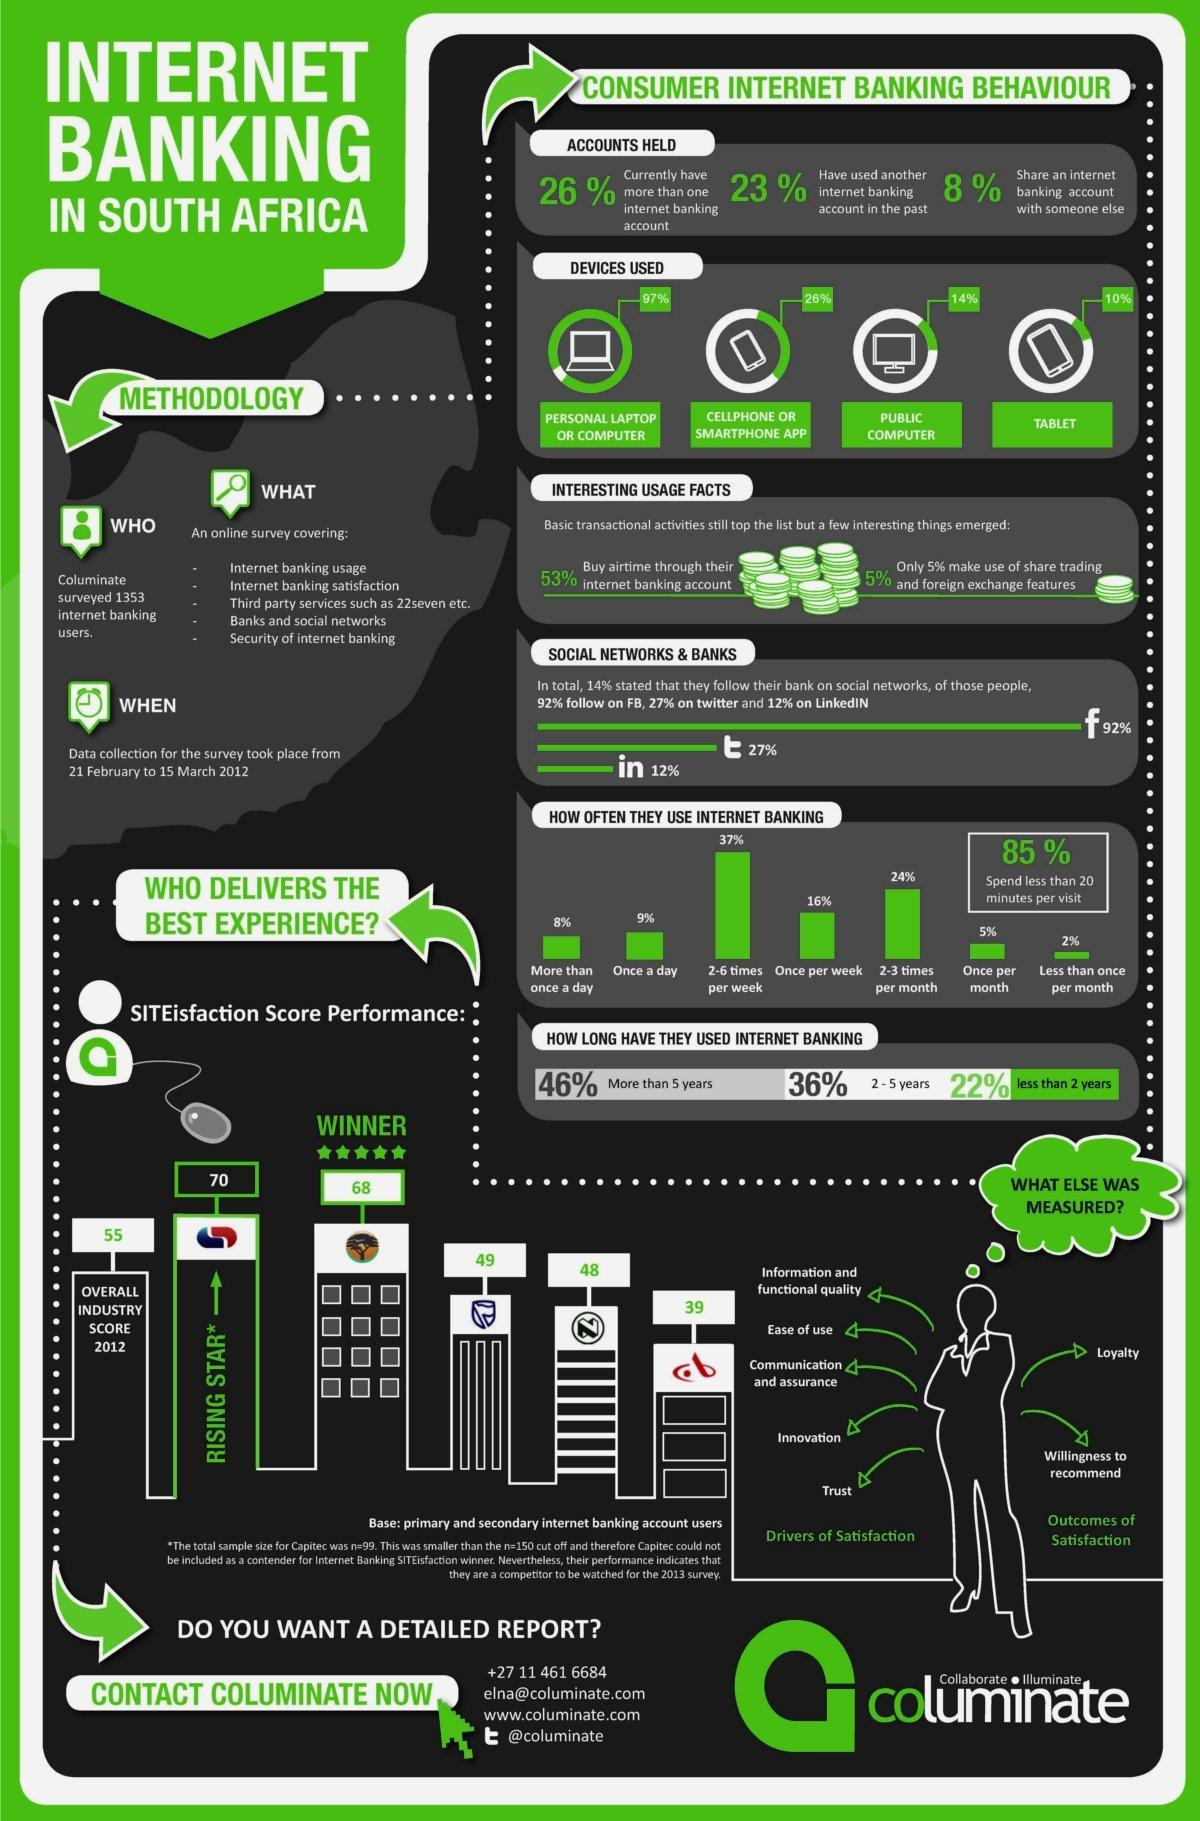Specify some key components in this picture. According to a survey conducted in 2012, 26% of consumers in South Africa use internet banking via their smartphone app. According to a survey conducted in South Africa in 2012, only 5% of consumers used internet banking on a monthly basis. A survey conducted in South Africa in 2012 showed that tablets were the least commonly used device for internet banking among consumers. According to a survey conducted in 2012 in South Africa, 8% of consumers shared an internet banking account with someone else. In 2012, the satisfaction score performance of Capitec Bank in South Africa was 70%. 